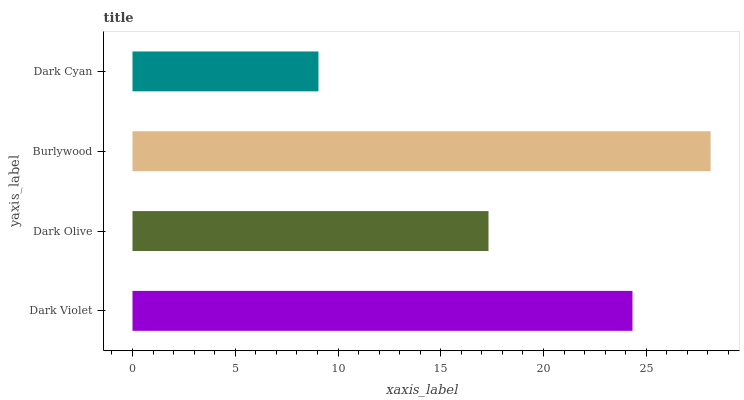Is Dark Cyan the minimum?
Answer yes or no. Yes. Is Burlywood the maximum?
Answer yes or no. Yes. Is Dark Olive the minimum?
Answer yes or no. No. Is Dark Olive the maximum?
Answer yes or no. No. Is Dark Violet greater than Dark Olive?
Answer yes or no. Yes. Is Dark Olive less than Dark Violet?
Answer yes or no. Yes. Is Dark Olive greater than Dark Violet?
Answer yes or no. No. Is Dark Violet less than Dark Olive?
Answer yes or no. No. Is Dark Violet the high median?
Answer yes or no. Yes. Is Dark Olive the low median?
Answer yes or no. Yes. Is Burlywood the high median?
Answer yes or no. No. Is Burlywood the low median?
Answer yes or no. No. 